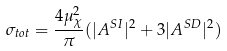<formula> <loc_0><loc_0><loc_500><loc_500>\sigma _ { t o t } = \frac { 4 \mu _ { \chi } ^ { 2 } } { \pi } ( | A ^ { S I } | ^ { 2 } + 3 | A ^ { S D } | ^ { 2 } )</formula> 